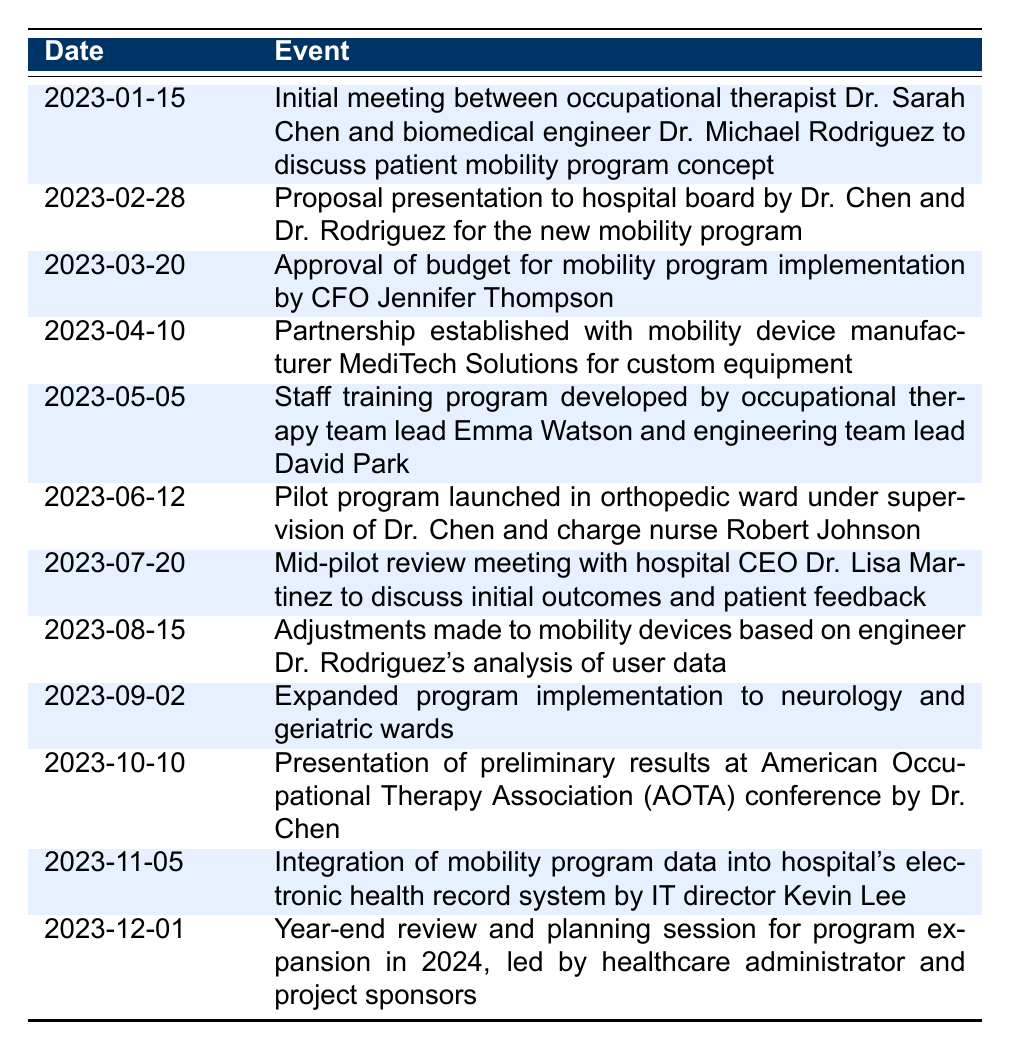What date did the initial meeting between Dr. Chen and Dr. Rodriguez take place? The event of the initial meeting is listed in the table with the date "2023-01-15".
Answer: 2023-01-15 Who presented the proposal to the hospital board? The event indicates that both Dr. Chen and Dr. Rodriguez presented the proposal, thus specifying their involvement.
Answer: Dr. Chen and Dr. Rodriguez Was there a mid-pilot review meeting with the hospital CEO? The table explicitly states that there was a mid-pilot review meeting involving the CEO on "2023-07-20".
Answer: Yes How many months passed between the initial meeting and the program approval? The initial meeting occurred on "2023-01-15" and the program approval on "2023-03-20". Counting the months (February and March), there are a total of 2 months between these two dates.
Answer: 2 What adjustments were made to the mobility devices, and when? According to the table, adjustments to the mobility devices were made on "2023-08-15" based on Dr. Rodriguez's analysis of user data.
Answer: Adjustments made on 2023-08-15 What two wards were included in the expanded program implementation? The table mentions the expanded program implementation was carried out in the neurology and geriatric wards, providing a clear identification of these wards.
Answer: Neurology and geriatric wards How long did the pilot program run before the mid-pilot review meeting? The pilot program launched on "2023-06-12", and the mid-pilot review meeting was on "2023-07-20". The duration between these dates is 38 days, which is a little over one month.
Answer: 38 days What significant integration occurred on November 5, 2023? The table indicates that on this date, the mobility program data was integrated into the hospital's electronic health record system by IT director Kevin Lee.
Answer: Integration of mobility program data into EHR system What was the focus of the year-end review planned for December 1? The year-end review focused on planning for program expansion in 2024, according to the entry for this date in the table.
Answer: Program expansion in 2024 